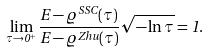Convert formula to latex. <formula><loc_0><loc_0><loc_500><loc_500>\lim _ { \tau \to 0 ^ { + } } \frac { E - \varrho ^ { S S C } ( \tau ) } { E - \varrho ^ { Z h u } ( \tau ) } \sqrt { - \ln \tau } = 1 .</formula> 